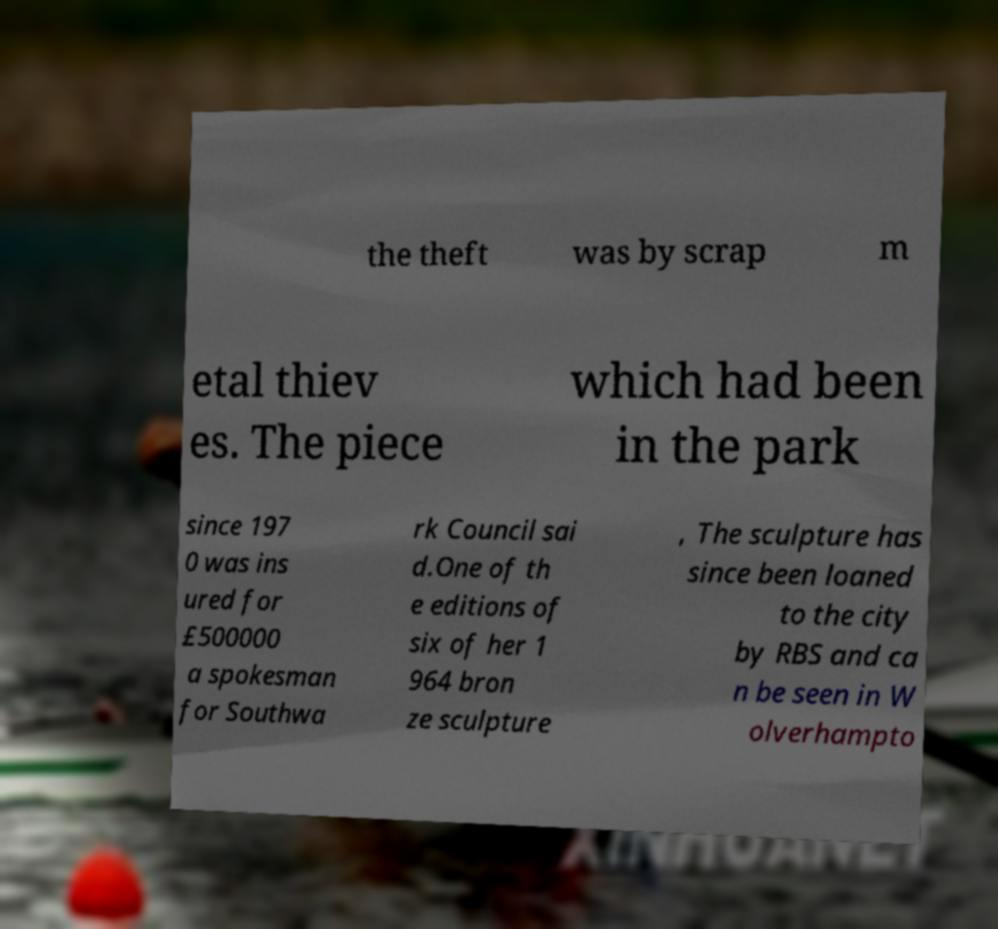Could you extract and type out the text from this image? the theft was by scrap m etal thiev es. The piece which had been in the park since 197 0 was ins ured for £500000 a spokesman for Southwa rk Council sai d.One of th e editions of six of her 1 964 bron ze sculpture , The sculpture has since been loaned to the city by RBS and ca n be seen in W olverhampto 